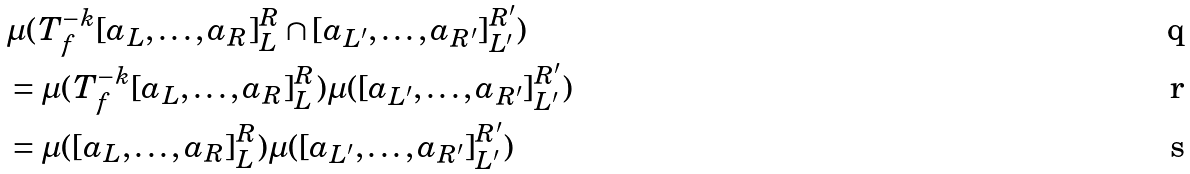Convert formula to latex. <formula><loc_0><loc_0><loc_500><loc_500>& \mu ( T _ { f } ^ { - k } [ a _ { L } , \dots , a _ { R } ] _ { L } ^ { R } \cap [ a _ { L ^ { \prime } } , \dots , a _ { R ^ { \prime } } ] _ { L ^ { \prime } } ^ { R ^ { \prime } } ) \\ & = \mu ( T _ { f } ^ { - k } [ a _ { L } , \dots , a _ { R } ] _ { L } ^ { R } ) \mu ( [ a _ { L ^ { \prime } } , \dots , a _ { R ^ { \prime } } ] _ { L ^ { \prime } } ^ { R ^ { \prime } } ) \\ & = \mu ( [ a _ { L } , \dots , a _ { R } ] _ { L } ^ { R } ) \mu ( [ a _ { L ^ { \prime } } , \dots , a _ { R ^ { \prime } } ] _ { L ^ { \prime } } ^ { R ^ { \prime } } )</formula> 